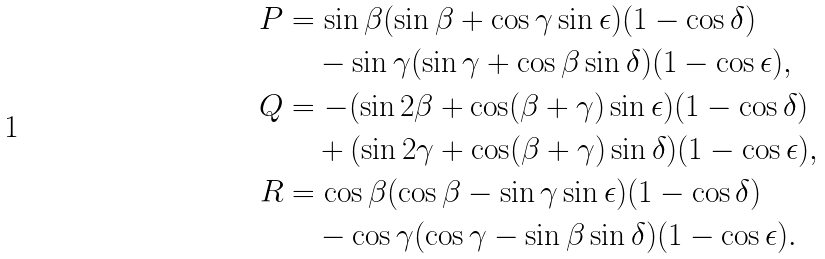<formula> <loc_0><loc_0><loc_500><loc_500>P & = \sin \beta ( \sin \beta + \cos \gamma \sin \epsilon ) ( 1 - \cos \delta ) \\ & \quad - \sin \gamma ( \sin \gamma + \cos \beta \sin \delta ) ( 1 - \cos \epsilon ) , \\ Q & = - ( \sin 2 \beta + \cos ( \beta + \gamma ) \sin \epsilon ) ( 1 - \cos \delta ) \\ & \quad + ( \sin 2 \gamma + \cos ( \beta + \gamma ) \sin \delta ) ( 1 - \cos \epsilon ) , \\ R & = \cos \beta ( \cos \beta - \sin \gamma \sin \epsilon ) ( 1 - \cos \delta ) \\ & \quad - \cos \gamma ( \cos \gamma - \sin \beta \sin \delta ) ( 1 - \cos \epsilon ) .</formula> 